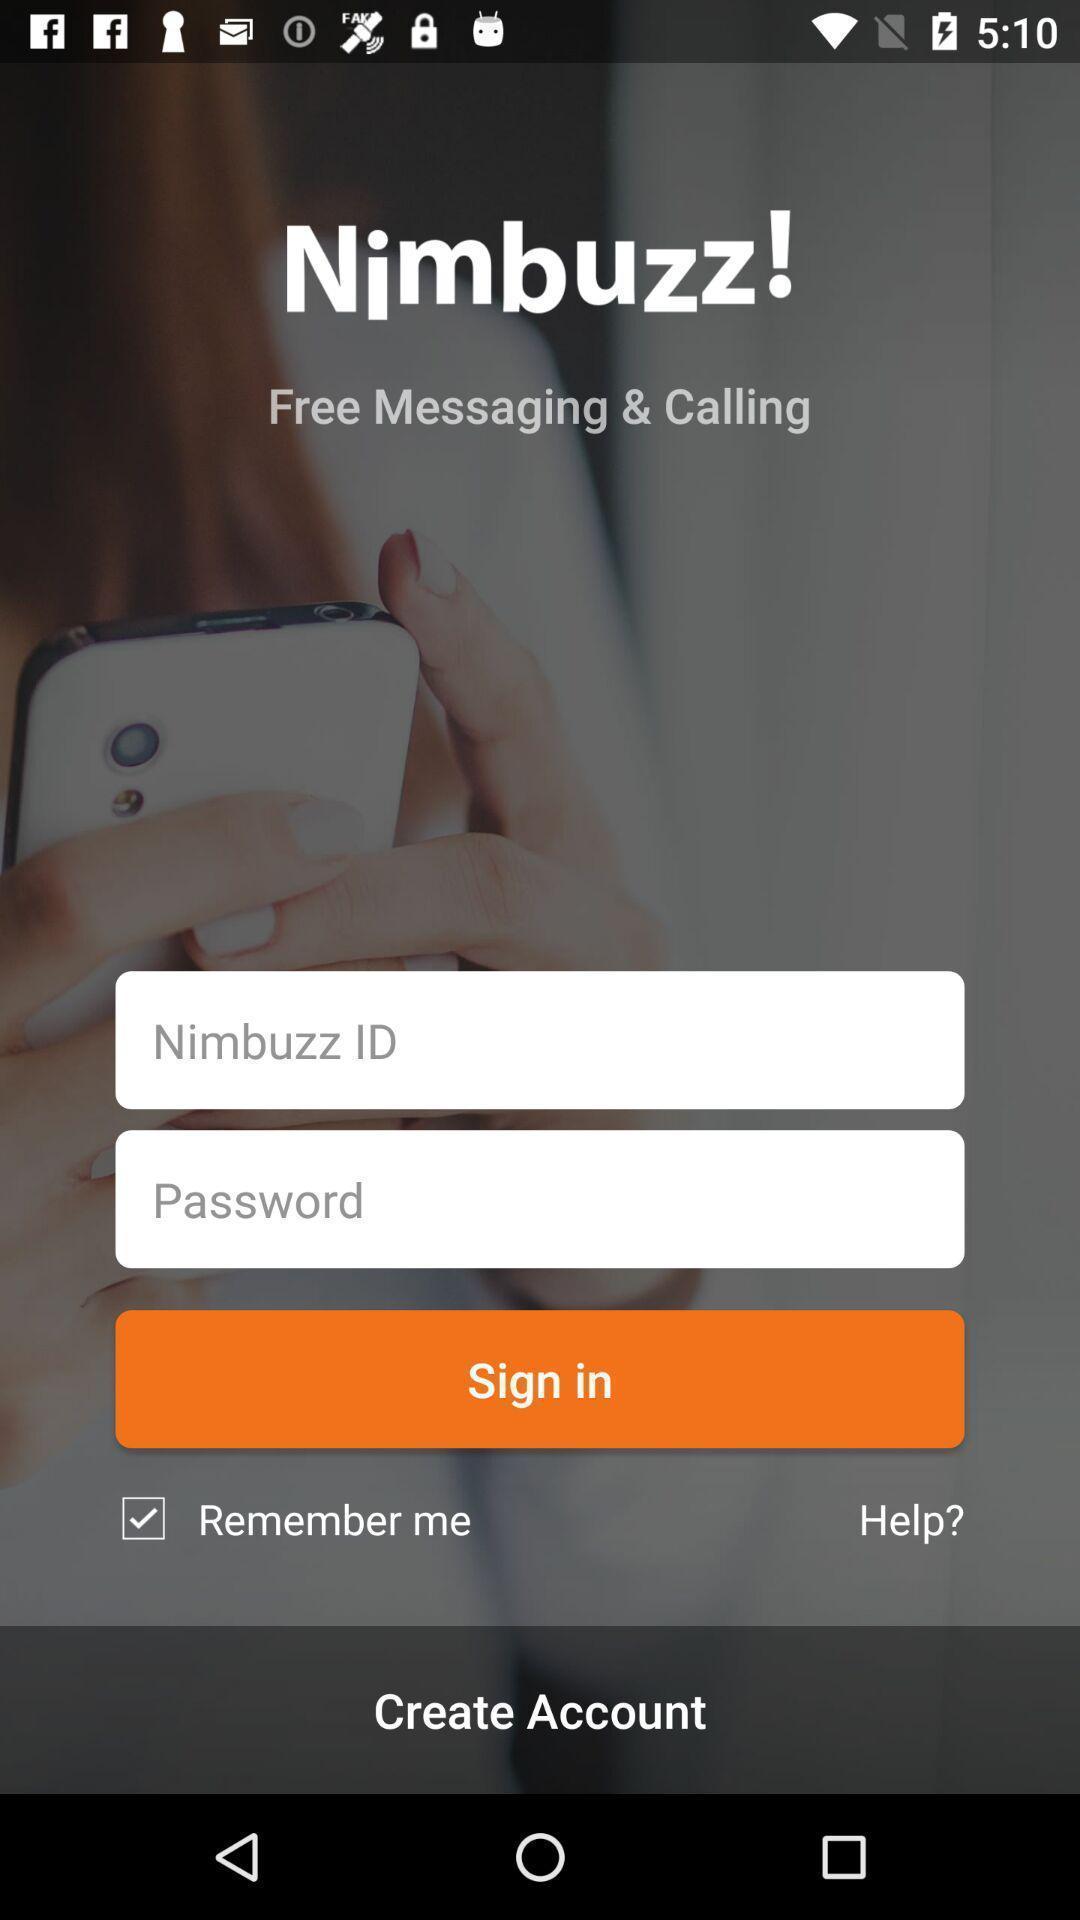Please provide a description for this image. Signin page. 